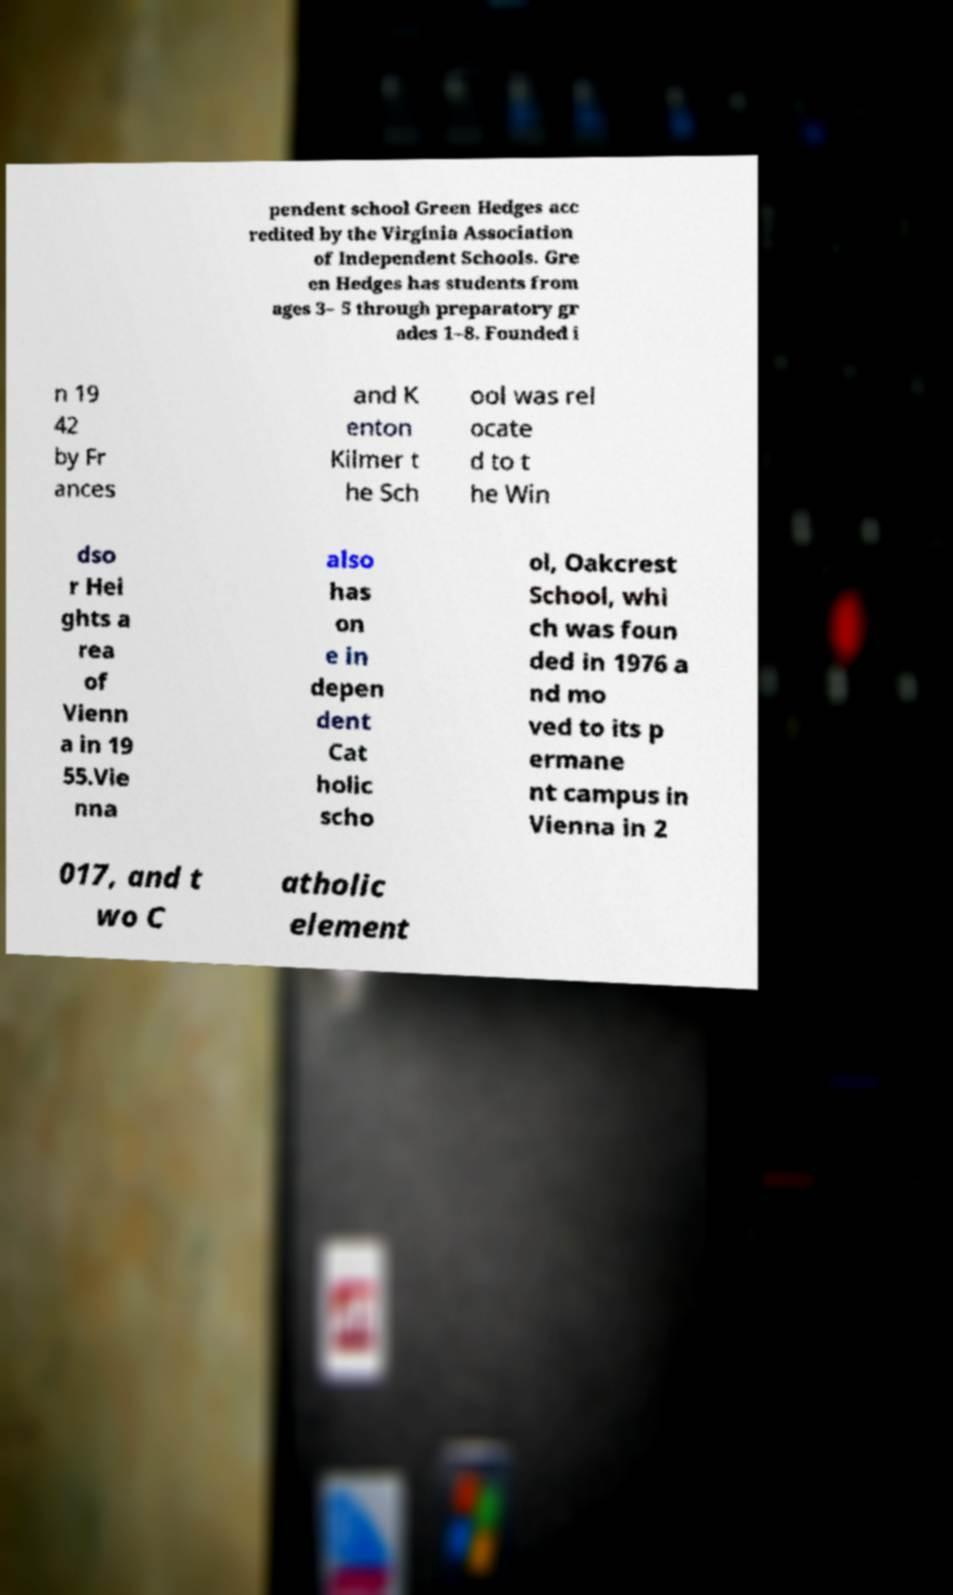Can you read and provide the text displayed in the image?This photo seems to have some interesting text. Can you extract and type it out for me? pendent school Green Hedges acc redited by the Virginia Association of Independent Schools. Gre en Hedges has students from ages 3– 5 through preparatory gr ades 1–8. Founded i n 19 42 by Fr ances and K enton Kilmer t he Sch ool was rel ocate d to t he Win dso r Hei ghts a rea of Vienn a in 19 55.Vie nna also has on e in depen dent Cat holic scho ol, Oakcrest School, whi ch was foun ded in 1976 a nd mo ved to its p ermane nt campus in Vienna in 2 017, and t wo C atholic element 